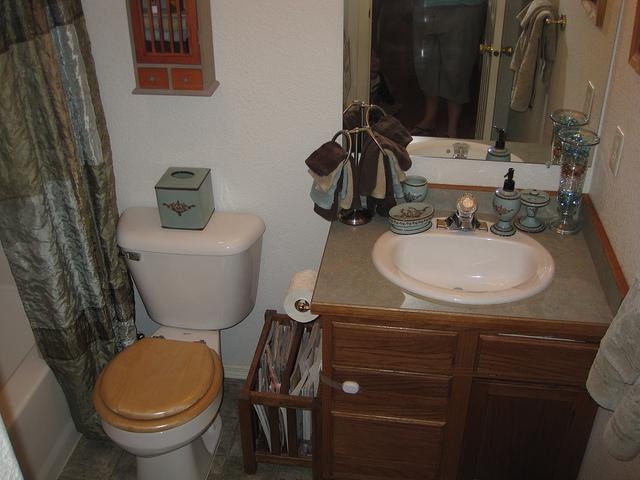What is the box on the toilet tank used for? Please explain your reasoning. tissue boxes. This holds kleenex 